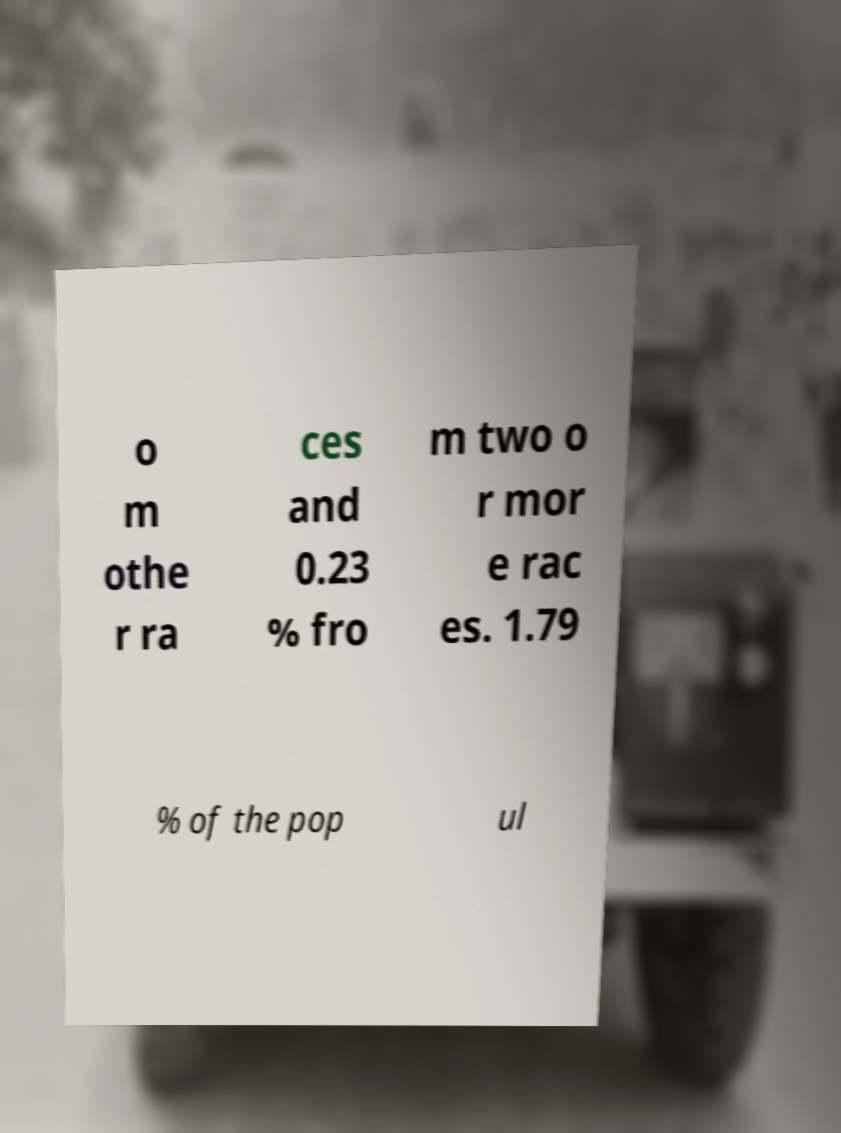Please identify and transcribe the text found in this image. o m othe r ra ces and 0.23 % fro m two o r mor e rac es. 1.79 % of the pop ul 